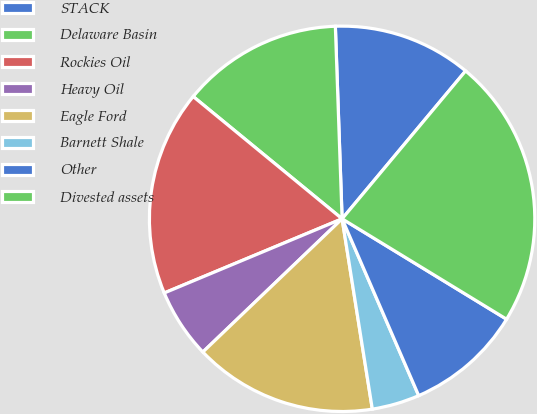Convert chart to OTSL. <chart><loc_0><loc_0><loc_500><loc_500><pie_chart><fcel>STACK<fcel>Delaware Basin<fcel>Rockies Oil<fcel>Heavy Oil<fcel>Eagle Ford<fcel>Barnett Shale<fcel>Other<fcel>Divested assets<nl><fcel>11.63%<fcel>13.5%<fcel>17.23%<fcel>5.86%<fcel>15.36%<fcel>4.0%<fcel>9.77%<fcel>22.65%<nl></chart> 